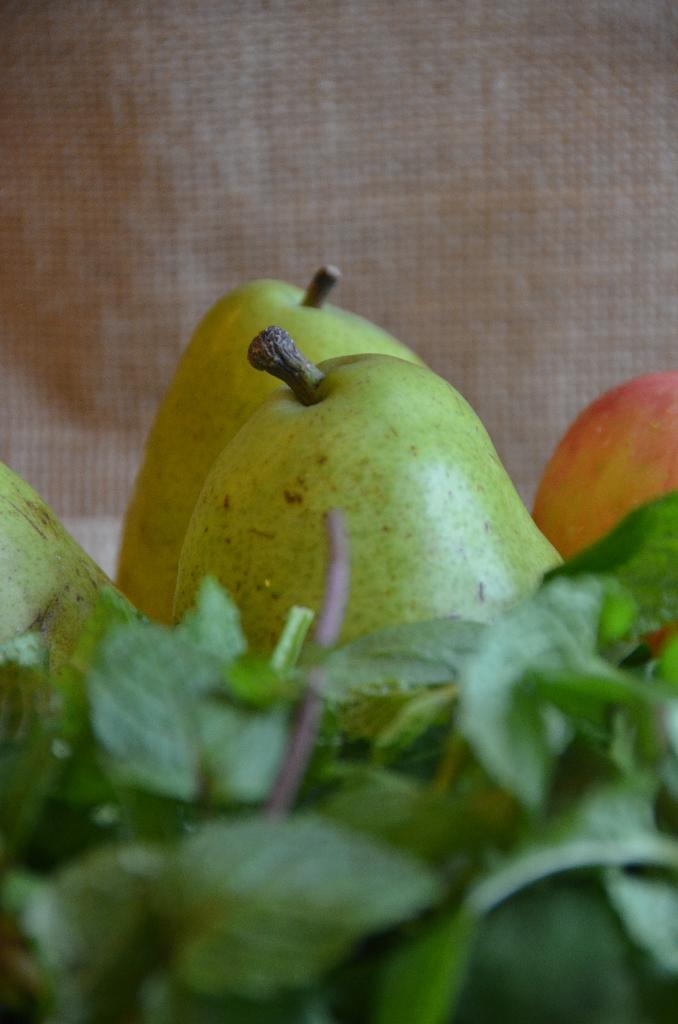What type of food can be seen in the image? The image contains fruits. Are there any additional elements associated with the fruits? Yes, the fruits are accompanied by leaves. What can be seen in the background of the image? There is a mat visible in the background of the image. How many beggars are present in the image? There are no beggars present in the image; it features fruits accompanied by leaves and a mat in the background. What type of cakes can be seen in the image? There are no cakes present in the image; it features fruits accompanied by leaves and a mat in the background. 